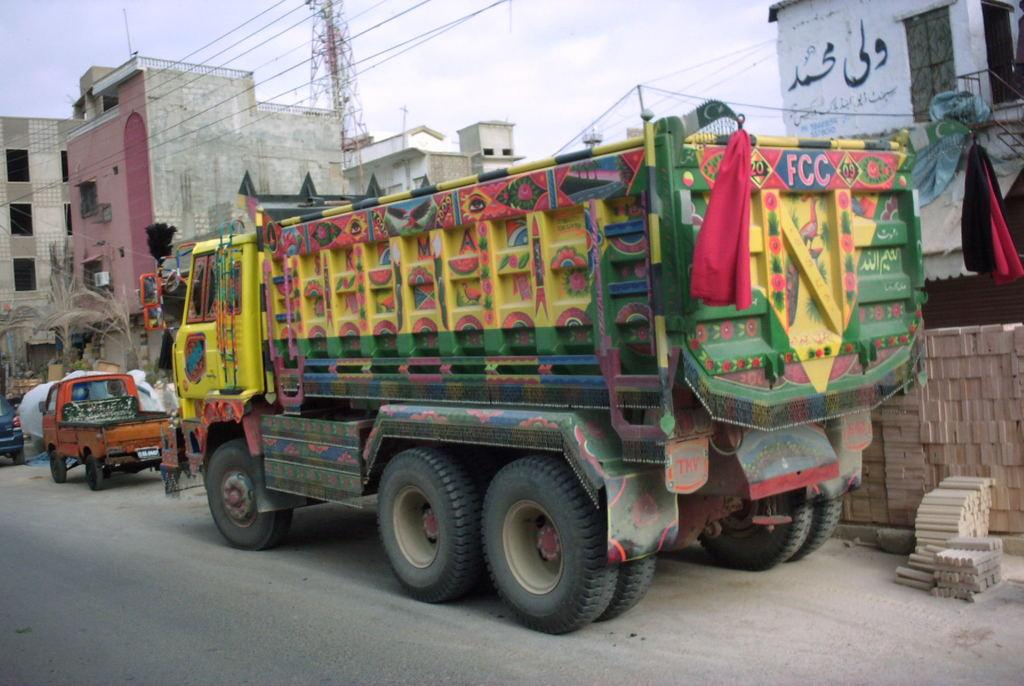What types of man-made structures are visible in the image? There are vehicles, buildings, and electrical poles in the image. Can you describe the vehicles in the image? The provided facts do not give specific details about the vehicles, so we cannot describe them further. What else can be seen in the image besides vehicles and buildings? Electrical poles are also visible in the image. How many beans are scattered on the ground in the image? There are no beans present in the image. Is there any quicksand visible in the image? There is no quicksand present in the image. 